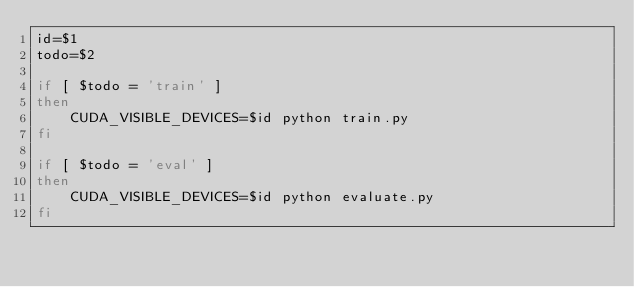Convert code to text. <code><loc_0><loc_0><loc_500><loc_500><_Bash_>id=$1
todo=$2

if [ $todo = 'train' ]
then
    CUDA_VISIBLE_DEVICES=$id python train.py
fi

if [ $todo = 'eval' ]
then
    CUDA_VISIBLE_DEVICES=$id python evaluate.py
fi
</code> 